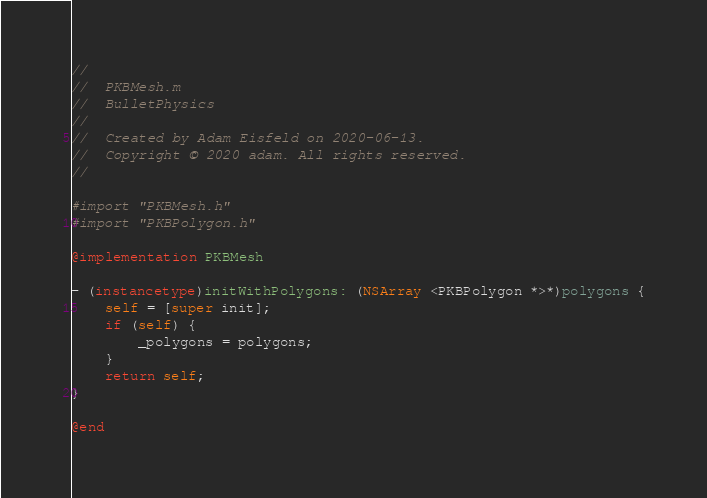Convert code to text. <code><loc_0><loc_0><loc_500><loc_500><_ObjectiveC_>//
//  PKBMesh.m
//  BulletPhysics
//
//  Created by Adam Eisfeld on 2020-06-13.
//  Copyright © 2020 adam. All rights reserved.
//

#import "PKBMesh.h"
#import "PKBPolygon.h"

@implementation PKBMesh

- (instancetype)initWithPolygons: (NSArray <PKBPolygon *>*)polygons {
    self = [super init];
    if (self) {
        _polygons = polygons;
    }
    return self;
}

@end
</code> 